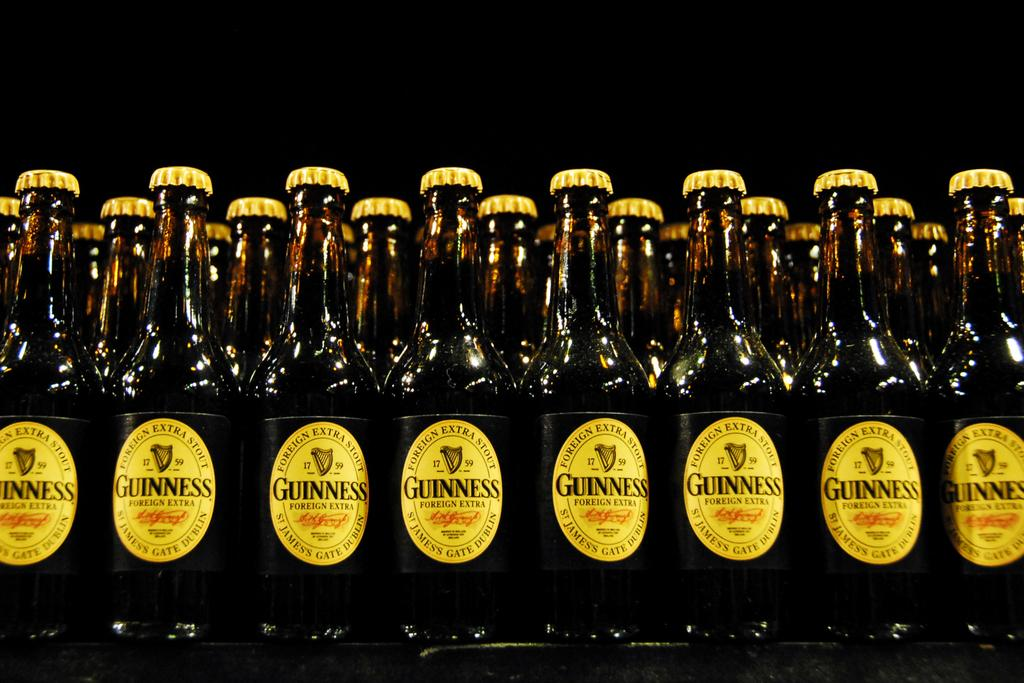<image>
Render a clear and concise summary of the photo. Bottles of Guinness with a yellow label sit next to each other. 